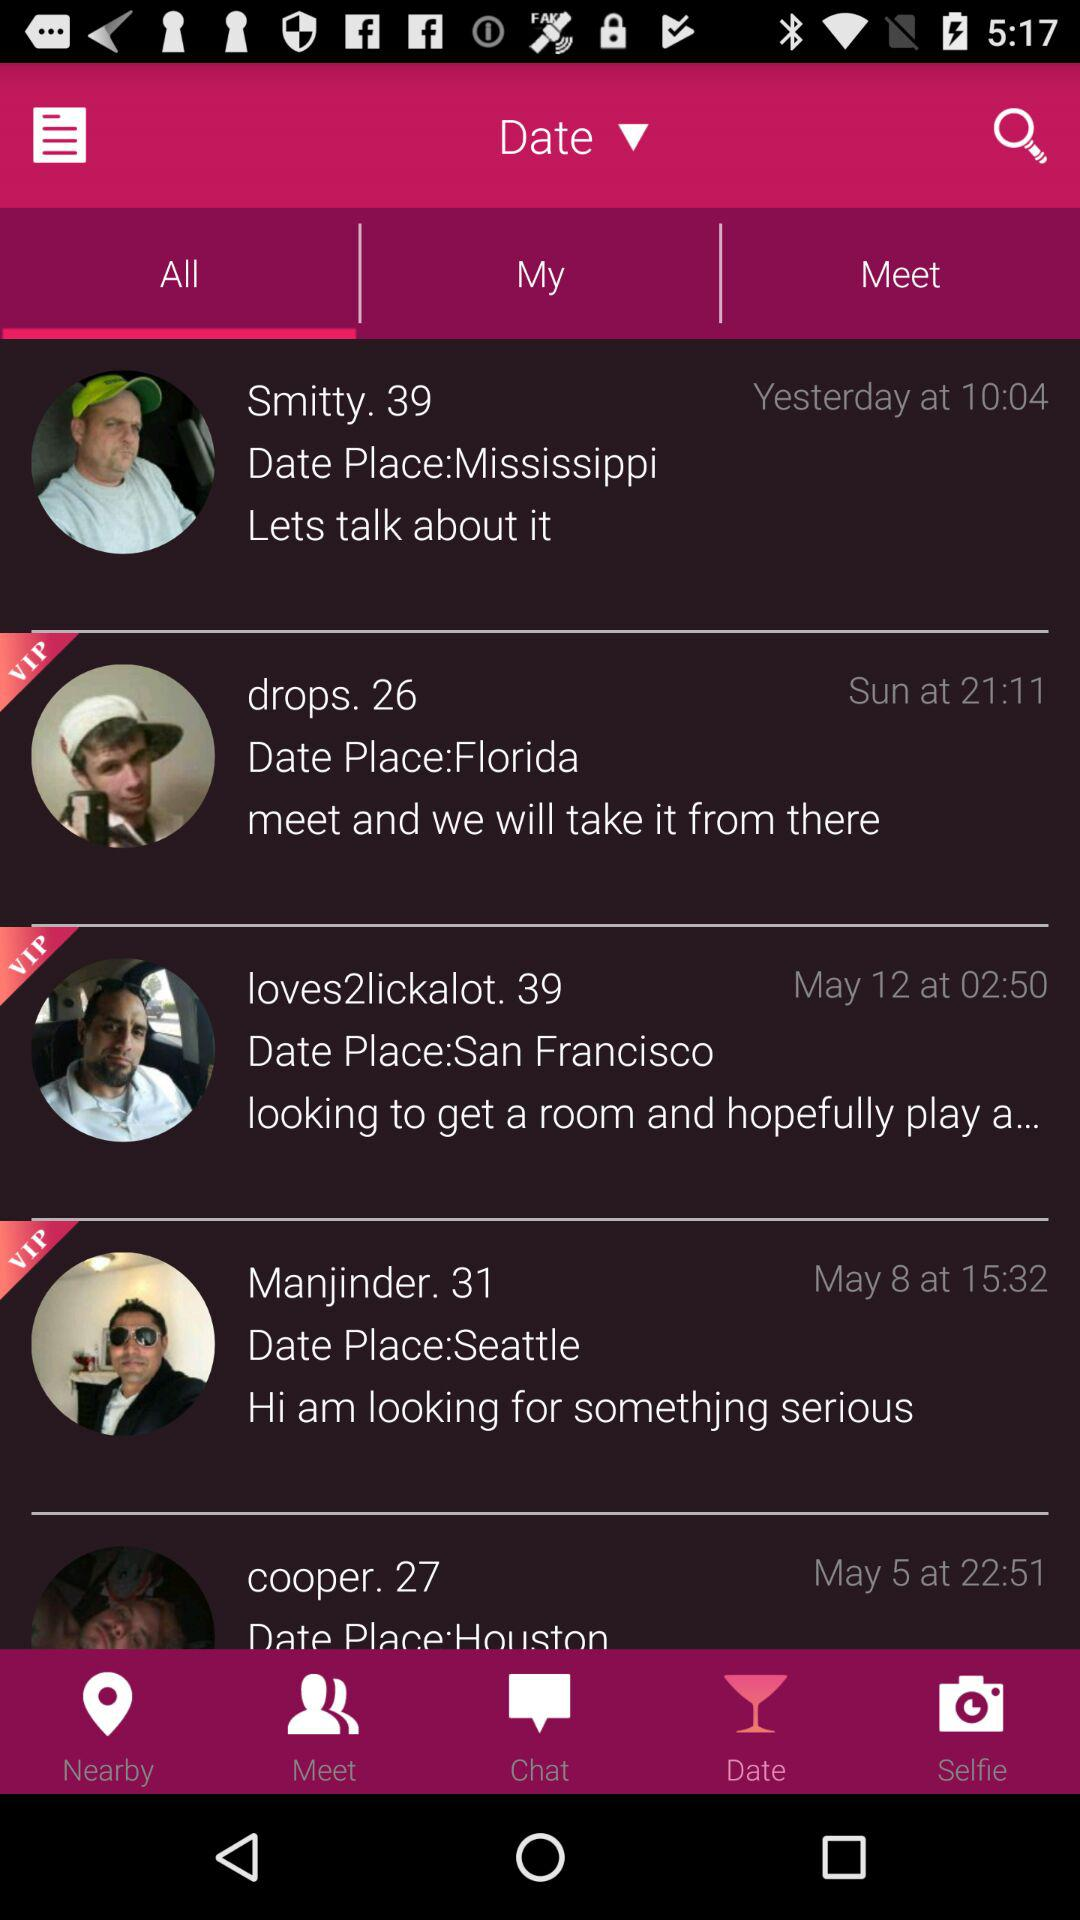What is the "Date Place" of Drops? The "Date Place" of Drops is Florida. 